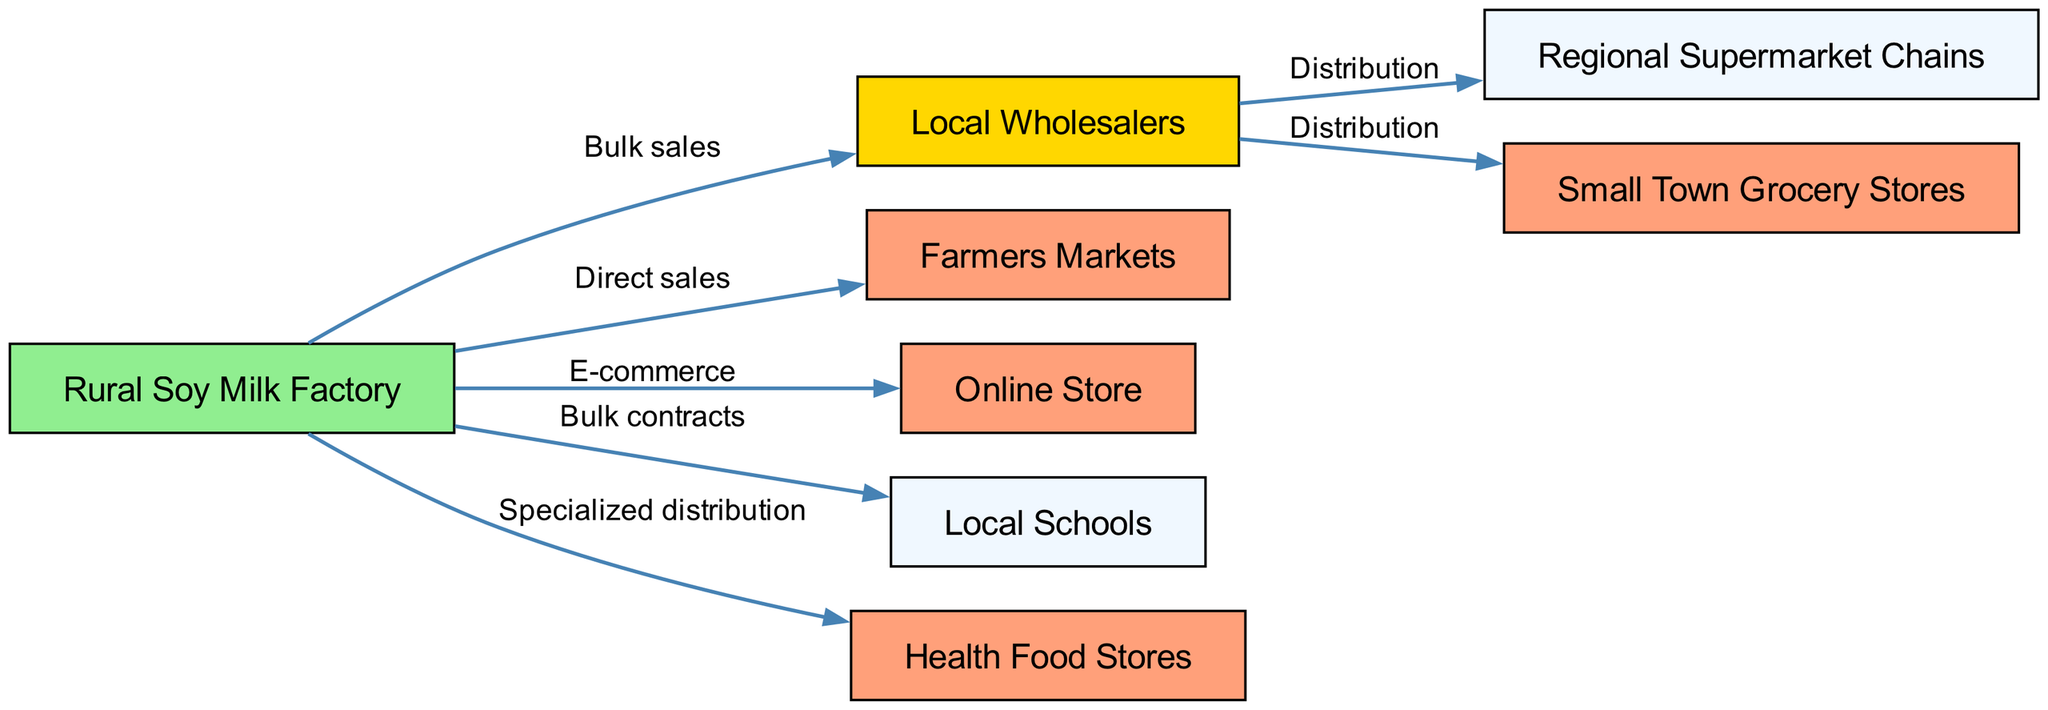What is the starting point of the distribution network? The distribution network begins with the "Rural Soy Milk Factory," which is the source of all sales and distribution connections depicted in the diagram.
Answer: Rural Soy Milk Factory How many nodes are present in the diagram? The diagram includes a total of eight nodes that represent different entities involved in the marketing and distribution of soy milk products.
Answer: 8 Which nodes are connected through the "Distribution" label? The "Local Wholesalers" node connects to two nodes: the "Regional Supermarket Chains" and the "Small Town Grocery Stores," which indicates that wholesalers distribute products to these retailers.
Answer: Regional Supermarket Chains, Small Town Grocery Stores What type of sales occurs directly from the Rural Soy Milk Factory? The "Rural Soy Milk Factory" engages in two types of direct sales activities: they sell directly to "Farmers Markets" and enter into bulk contracts with "Local Schools" for larger purchases.
Answer: Direct sales What flow does the "Health Food Stores" node exhibit? The "Health Food Stores" node receives products through specialized distribution that comes directly from the "Rural Soy Milk Factory," indicating a targeted sales strategy.
Answer: Specialized distribution How many direct-to-consumer options are indicated in the diagram? The diagram shows two direct-to-consumer options originating from the "Rural Soy Milk Factory": "Farmers Markets" and "Online Store," representing different ways to reach consumers directly.
Answer: 2 Where do Local Wholesalers distribute products? The "Local Wholesalers" distribute products specifically to "Regional Supermarket Chains" and "Small Town Grocery Stores," highlighting their role in the supply chain for these types of retail outlets.
Answer: Regional Supermarket Chains, Small Town Grocery Stores What type of contract is illustrated with Local Schools? The relationship between the "Rural Soy Milk Factory" and "Local Schools" is characterized as "Bulk contracts," indicating a business arrangement for supplying larger quantities of soy milk products to the schools.
Answer: Bulk contracts Which node is identified in the diagram as an online sales channel? The "Online Store" represents the e-commerce sales channel that connects directly with consumers, allowing them to purchase soy milk products online.
Answer: Online Store 